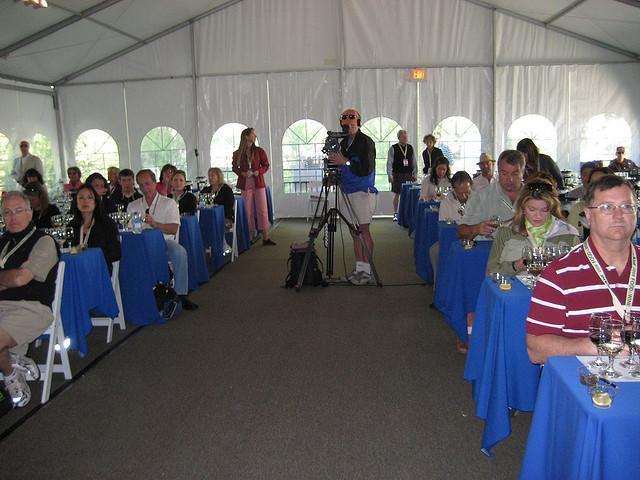How many chairs are in the picture?
Give a very brief answer. 1. How many dining tables are there?
Give a very brief answer. 4. How many people are there?
Give a very brief answer. 9. How many cake clouds are there?
Give a very brief answer. 0. 